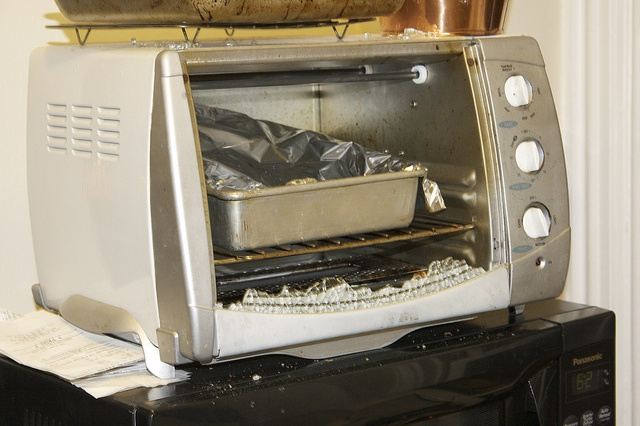Describe the objects in this image and their specific colors. I can see oven in beige, lightgray, tan, and darkgray tones and microwave in beige, black, and gray tones in this image. 